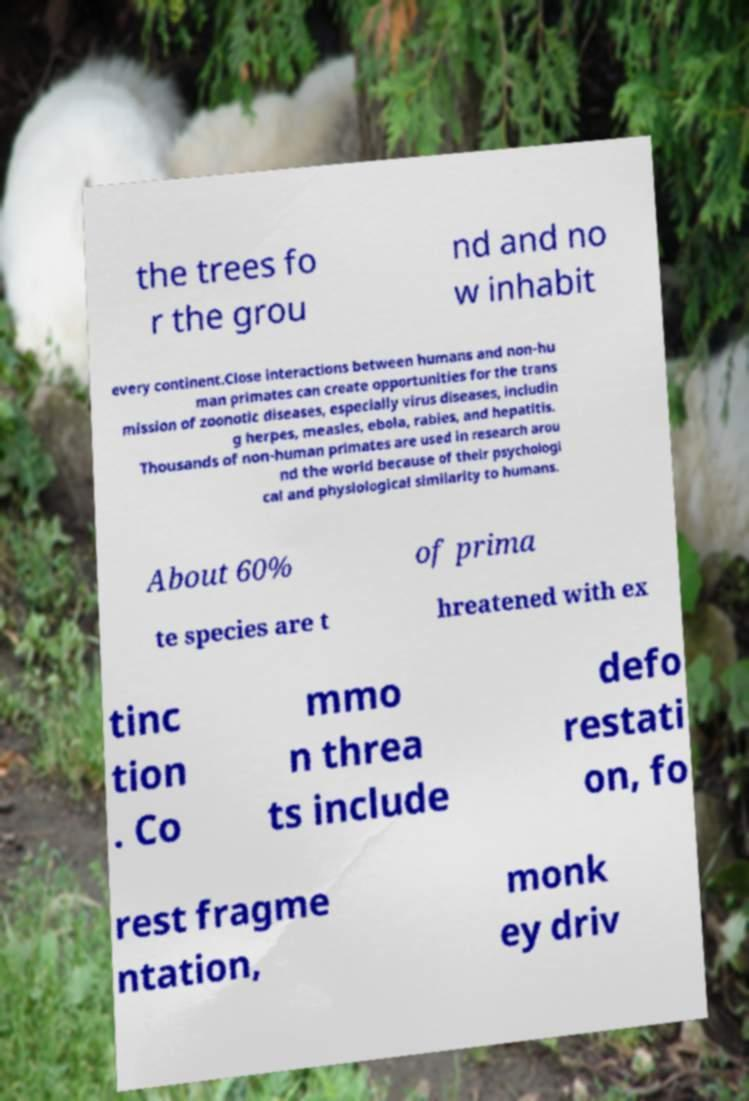Can you read and provide the text displayed in the image?This photo seems to have some interesting text. Can you extract and type it out for me? the trees fo r the grou nd and no w inhabit every continent.Close interactions between humans and non-hu man primates can create opportunities for the trans mission of zoonotic diseases, especially virus diseases, includin g herpes, measles, ebola, rabies, and hepatitis. Thousands of non-human primates are used in research arou nd the world because of their psychologi cal and physiological similarity to humans. About 60% of prima te species are t hreatened with ex tinc tion . Co mmo n threa ts include defo restati on, fo rest fragme ntation, monk ey driv 